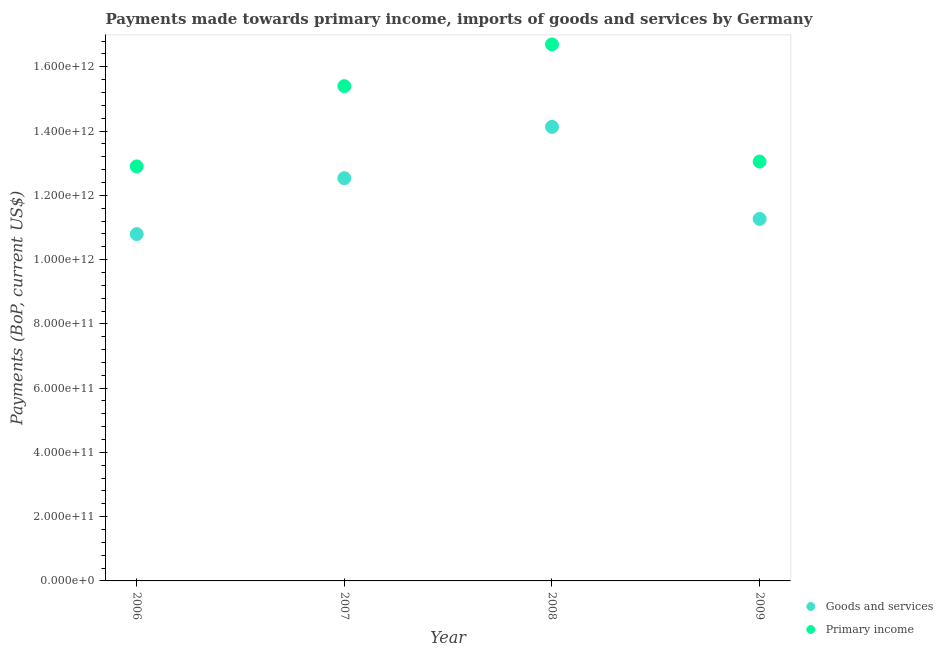How many different coloured dotlines are there?
Provide a succinct answer. 2. What is the payments made towards goods and services in 2009?
Your answer should be very brief. 1.13e+12. Across all years, what is the maximum payments made towards goods and services?
Provide a succinct answer. 1.41e+12. Across all years, what is the minimum payments made towards goods and services?
Keep it short and to the point. 1.08e+12. In which year was the payments made towards goods and services minimum?
Your answer should be compact. 2006. What is the total payments made towards goods and services in the graph?
Offer a very short reply. 4.87e+12. What is the difference between the payments made towards primary income in 2008 and that in 2009?
Provide a short and direct response. 3.65e+11. What is the difference between the payments made towards primary income in 2007 and the payments made towards goods and services in 2006?
Offer a very short reply. 4.61e+11. What is the average payments made towards primary income per year?
Keep it short and to the point. 1.45e+12. In the year 2007, what is the difference between the payments made towards primary income and payments made towards goods and services?
Your answer should be very brief. 2.86e+11. What is the ratio of the payments made towards goods and services in 2006 to that in 2007?
Provide a succinct answer. 0.86. Is the payments made towards primary income in 2007 less than that in 2008?
Keep it short and to the point. Yes. Is the difference between the payments made towards goods and services in 2006 and 2008 greater than the difference between the payments made towards primary income in 2006 and 2008?
Keep it short and to the point. Yes. What is the difference between the highest and the second highest payments made towards goods and services?
Provide a short and direct response. 1.60e+11. What is the difference between the highest and the lowest payments made towards primary income?
Give a very brief answer. 3.80e+11. Is the sum of the payments made towards goods and services in 2006 and 2008 greater than the maximum payments made towards primary income across all years?
Offer a terse response. Yes. What is the difference between two consecutive major ticks on the Y-axis?
Make the answer very short. 2.00e+11. Are the values on the major ticks of Y-axis written in scientific E-notation?
Give a very brief answer. Yes. Does the graph contain any zero values?
Your response must be concise. No. How are the legend labels stacked?
Your response must be concise. Vertical. What is the title of the graph?
Offer a terse response. Payments made towards primary income, imports of goods and services by Germany. What is the label or title of the X-axis?
Make the answer very short. Year. What is the label or title of the Y-axis?
Provide a succinct answer. Payments (BoP, current US$). What is the Payments (BoP, current US$) of Goods and services in 2006?
Your response must be concise. 1.08e+12. What is the Payments (BoP, current US$) in Primary income in 2006?
Offer a terse response. 1.29e+12. What is the Payments (BoP, current US$) of Goods and services in 2007?
Provide a succinct answer. 1.25e+12. What is the Payments (BoP, current US$) of Primary income in 2007?
Keep it short and to the point. 1.54e+12. What is the Payments (BoP, current US$) of Goods and services in 2008?
Your response must be concise. 1.41e+12. What is the Payments (BoP, current US$) in Primary income in 2008?
Give a very brief answer. 1.67e+12. What is the Payments (BoP, current US$) in Goods and services in 2009?
Your answer should be compact. 1.13e+12. What is the Payments (BoP, current US$) of Primary income in 2009?
Your answer should be very brief. 1.31e+12. Across all years, what is the maximum Payments (BoP, current US$) in Goods and services?
Your response must be concise. 1.41e+12. Across all years, what is the maximum Payments (BoP, current US$) in Primary income?
Ensure brevity in your answer.  1.67e+12. Across all years, what is the minimum Payments (BoP, current US$) of Goods and services?
Offer a very short reply. 1.08e+12. Across all years, what is the minimum Payments (BoP, current US$) in Primary income?
Provide a short and direct response. 1.29e+12. What is the total Payments (BoP, current US$) of Goods and services in the graph?
Provide a short and direct response. 4.87e+12. What is the total Payments (BoP, current US$) in Primary income in the graph?
Your answer should be compact. 5.81e+12. What is the difference between the Payments (BoP, current US$) in Goods and services in 2006 and that in 2007?
Your answer should be compact. -1.74e+11. What is the difference between the Payments (BoP, current US$) of Primary income in 2006 and that in 2007?
Offer a terse response. -2.50e+11. What is the difference between the Payments (BoP, current US$) of Goods and services in 2006 and that in 2008?
Make the answer very short. -3.34e+11. What is the difference between the Payments (BoP, current US$) in Primary income in 2006 and that in 2008?
Offer a terse response. -3.80e+11. What is the difference between the Payments (BoP, current US$) of Goods and services in 2006 and that in 2009?
Your answer should be compact. -4.72e+1. What is the difference between the Payments (BoP, current US$) in Primary income in 2006 and that in 2009?
Keep it short and to the point. -1.51e+1. What is the difference between the Payments (BoP, current US$) in Goods and services in 2007 and that in 2008?
Offer a terse response. -1.60e+11. What is the difference between the Payments (BoP, current US$) of Primary income in 2007 and that in 2008?
Your answer should be compact. -1.30e+11. What is the difference between the Payments (BoP, current US$) of Goods and services in 2007 and that in 2009?
Ensure brevity in your answer.  1.27e+11. What is the difference between the Payments (BoP, current US$) of Primary income in 2007 and that in 2009?
Make the answer very short. 2.35e+11. What is the difference between the Payments (BoP, current US$) in Goods and services in 2008 and that in 2009?
Your answer should be very brief. 2.87e+11. What is the difference between the Payments (BoP, current US$) of Primary income in 2008 and that in 2009?
Ensure brevity in your answer.  3.65e+11. What is the difference between the Payments (BoP, current US$) of Goods and services in 2006 and the Payments (BoP, current US$) of Primary income in 2007?
Offer a very short reply. -4.61e+11. What is the difference between the Payments (BoP, current US$) in Goods and services in 2006 and the Payments (BoP, current US$) in Primary income in 2008?
Make the answer very short. -5.91e+11. What is the difference between the Payments (BoP, current US$) in Goods and services in 2006 and the Payments (BoP, current US$) in Primary income in 2009?
Make the answer very short. -2.26e+11. What is the difference between the Payments (BoP, current US$) of Goods and services in 2007 and the Payments (BoP, current US$) of Primary income in 2008?
Provide a succinct answer. -4.16e+11. What is the difference between the Payments (BoP, current US$) of Goods and services in 2007 and the Payments (BoP, current US$) of Primary income in 2009?
Your answer should be compact. -5.17e+1. What is the difference between the Payments (BoP, current US$) of Goods and services in 2008 and the Payments (BoP, current US$) of Primary income in 2009?
Make the answer very short. 1.08e+11. What is the average Payments (BoP, current US$) of Goods and services per year?
Your answer should be very brief. 1.22e+12. What is the average Payments (BoP, current US$) of Primary income per year?
Offer a terse response. 1.45e+12. In the year 2006, what is the difference between the Payments (BoP, current US$) in Goods and services and Payments (BoP, current US$) in Primary income?
Your answer should be very brief. -2.11e+11. In the year 2007, what is the difference between the Payments (BoP, current US$) in Goods and services and Payments (BoP, current US$) in Primary income?
Keep it short and to the point. -2.86e+11. In the year 2008, what is the difference between the Payments (BoP, current US$) in Goods and services and Payments (BoP, current US$) in Primary income?
Offer a very short reply. -2.57e+11. In the year 2009, what is the difference between the Payments (BoP, current US$) in Goods and services and Payments (BoP, current US$) in Primary income?
Offer a terse response. -1.79e+11. What is the ratio of the Payments (BoP, current US$) of Goods and services in 2006 to that in 2007?
Keep it short and to the point. 0.86. What is the ratio of the Payments (BoP, current US$) in Primary income in 2006 to that in 2007?
Provide a short and direct response. 0.84. What is the ratio of the Payments (BoP, current US$) of Goods and services in 2006 to that in 2008?
Offer a terse response. 0.76. What is the ratio of the Payments (BoP, current US$) in Primary income in 2006 to that in 2008?
Provide a short and direct response. 0.77. What is the ratio of the Payments (BoP, current US$) of Goods and services in 2006 to that in 2009?
Your answer should be very brief. 0.96. What is the ratio of the Payments (BoP, current US$) in Primary income in 2006 to that in 2009?
Offer a very short reply. 0.99. What is the ratio of the Payments (BoP, current US$) of Goods and services in 2007 to that in 2008?
Offer a terse response. 0.89. What is the ratio of the Payments (BoP, current US$) in Primary income in 2007 to that in 2008?
Your answer should be compact. 0.92. What is the ratio of the Payments (BoP, current US$) of Goods and services in 2007 to that in 2009?
Make the answer very short. 1.11. What is the ratio of the Payments (BoP, current US$) of Primary income in 2007 to that in 2009?
Your answer should be very brief. 1.18. What is the ratio of the Payments (BoP, current US$) in Goods and services in 2008 to that in 2009?
Ensure brevity in your answer.  1.25. What is the ratio of the Payments (BoP, current US$) of Primary income in 2008 to that in 2009?
Your answer should be very brief. 1.28. What is the difference between the highest and the second highest Payments (BoP, current US$) of Goods and services?
Your answer should be very brief. 1.60e+11. What is the difference between the highest and the second highest Payments (BoP, current US$) in Primary income?
Make the answer very short. 1.30e+11. What is the difference between the highest and the lowest Payments (BoP, current US$) of Goods and services?
Offer a terse response. 3.34e+11. What is the difference between the highest and the lowest Payments (BoP, current US$) of Primary income?
Keep it short and to the point. 3.80e+11. 